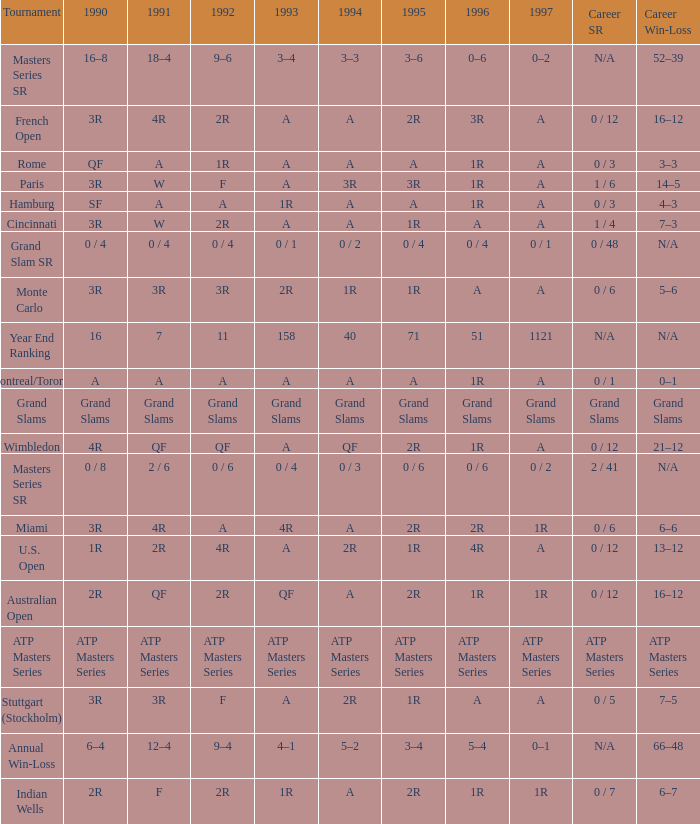What is 1997, when 1996 is "1R", when 1990 is "2R", and when 1991 is "F"? 1R. 